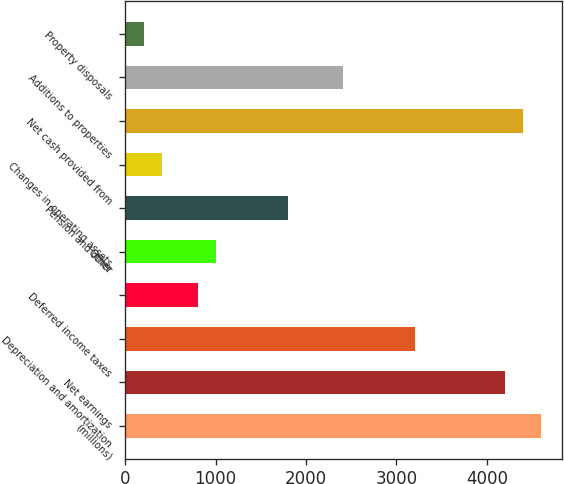Convert chart to OTSL. <chart><loc_0><loc_0><loc_500><loc_500><bar_chart><fcel>(millions)<fcel>Net earnings<fcel>Depreciation and amortization<fcel>Deferred income taxes<fcel>Other<fcel>Pension and other<fcel>Changes in operating assets<fcel>Net cash provided from<fcel>Additions to properties<fcel>Property disposals<nl><fcel>4600.1<fcel>4200.7<fcel>3202.2<fcel>805.8<fcel>1005.5<fcel>1804.3<fcel>406.4<fcel>4400.4<fcel>2403.4<fcel>206.7<nl></chart> 